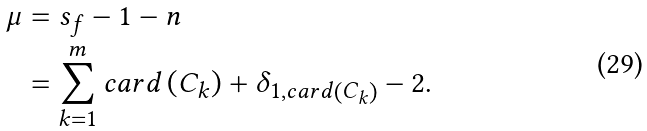Convert formula to latex. <formula><loc_0><loc_0><loc_500><loc_500>\mu & = s _ { f } - 1 - n \\ & = \sum _ { k = 1 } ^ { m } c a r d \left ( C _ { k } \right ) + \delta _ { 1 , c a r d \left ( C _ { k } \right ) } - 2 .</formula> 